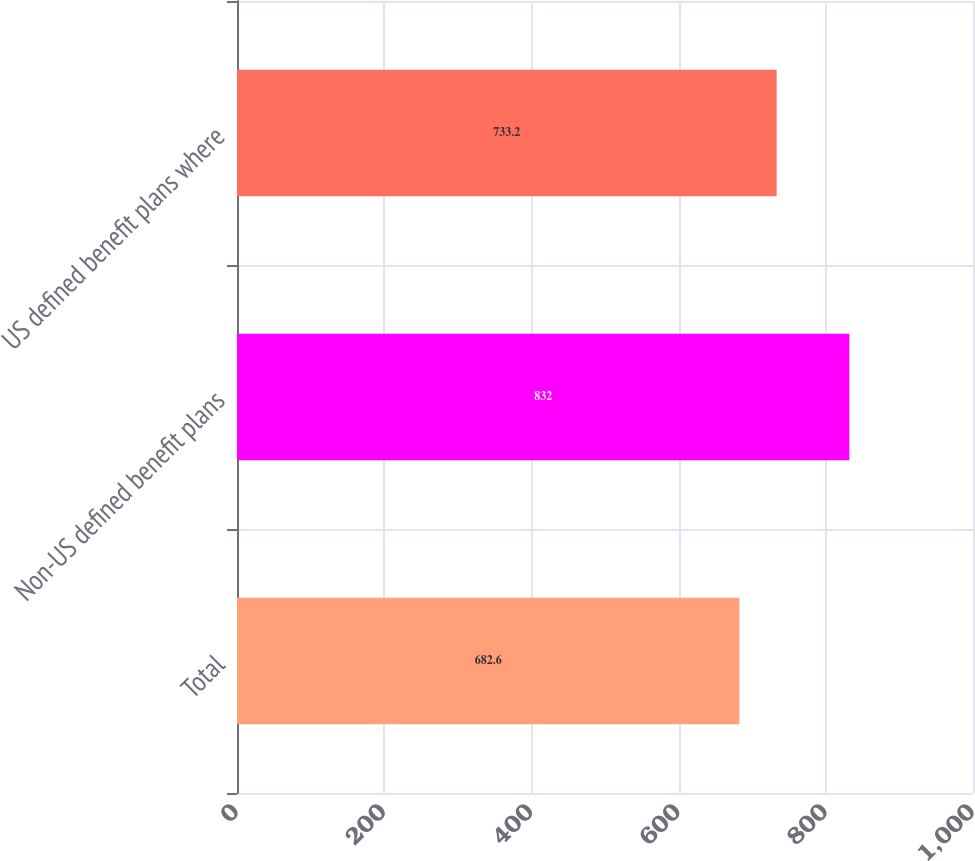Convert chart to OTSL. <chart><loc_0><loc_0><loc_500><loc_500><bar_chart><fcel>Total<fcel>Non-US defined benefit plans<fcel>US defined benefit plans where<nl><fcel>682.6<fcel>832<fcel>733.2<nl></chart> 